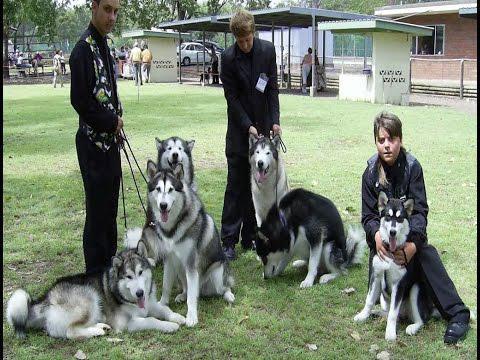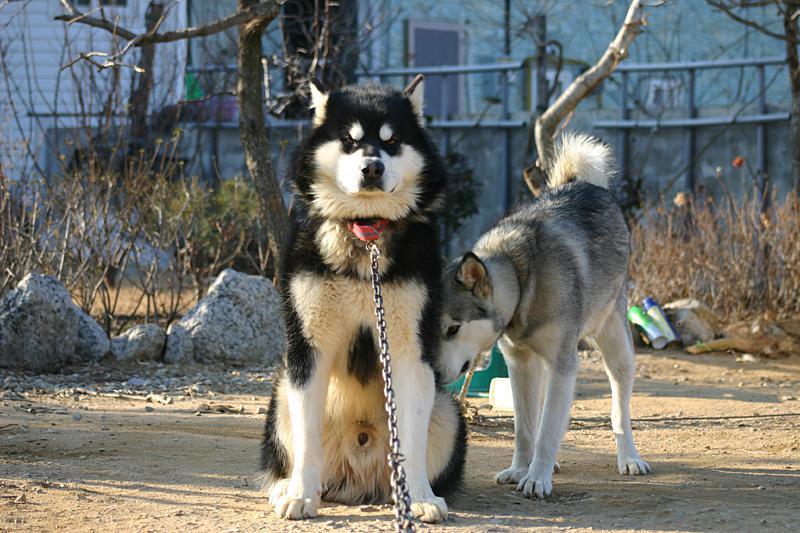The first image is the image on the left, the second image is the image on the right. For the images shown, is this caption "A dark-haired girl has her arms around at least one dog in one image, and the other image shows just one dog that is not interacting." true? Answer yes or no. No. The first image is the image on the left, the second image is the image on the right. Examine the images to the left and right. Is the description "The left image contains no more than one dog." accurate? Answer yes or no. No. 